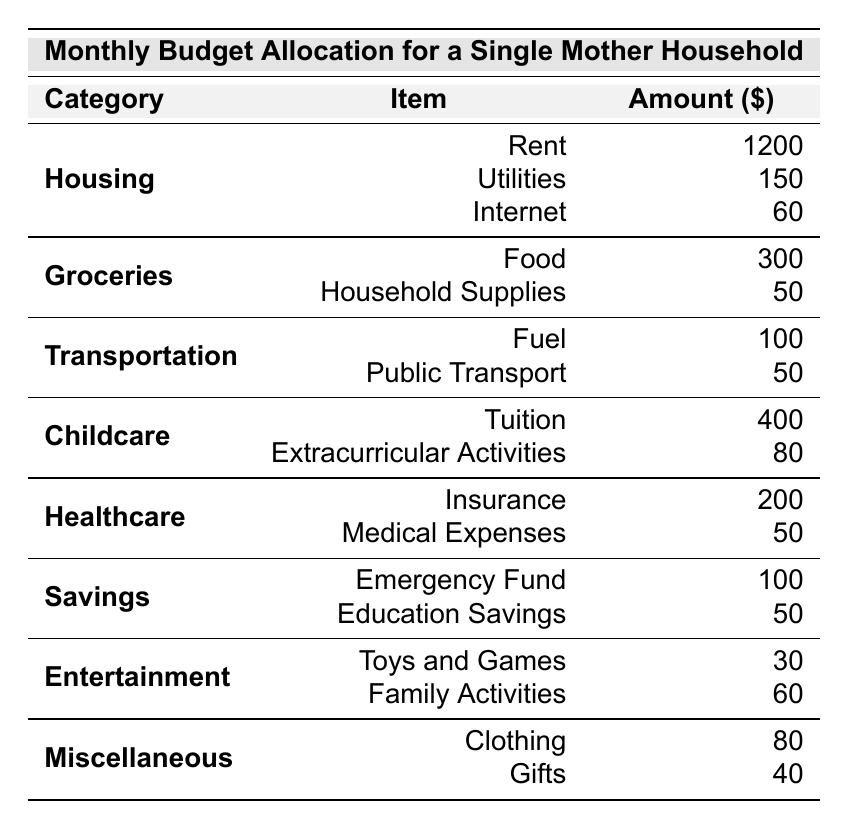What is the total amount allocated for Housing? To find the total, we add the allocations for Rent (1200), Utilities (150), and Internet (60). So, the total is 1200 + 150 + 60 = 1410.
Answer: 1410 How much more is spent on Groceries than on Transportation? The total for Groceries is 300 + 50 = 350, and the total for Transportation is 100 + 50 = 150. Subtract the Transportation total from the Groceries total: 350 - 150 = 200.
Answer: 200 What is the total budget for Childcare? The total for Childcare can be calculated by adding Tuition (400) and Extracurricular Activities (80), which gives us 400 + 80 = 480.
Answer: 480 Are the monthly expenses for Healthcare greater than those for Entertainment? The total for Healthcare is 200 + 50 = 250, whereas the total for Entertainment is 30 + 60 = 90. Since 250 is greater than 90, we confirm that it is true.
Answer: Yes What percentage of the total budget is allocated for Savings? First, calculate the total budget: 1200 + 150 + 60 + 300 + 50 + 100 + 50 + 400 + 80 + 200 + 50 + 100 + 50 + 30 + 60 + 80 + 40 =  2940. The total for Savings is 100 + 50 = 150. To find the percentage, we use the formula (150/2940) * 100 = approximately 5.1%.
Answer: 5.1% Which category has the highest individual expense? The highest individual expense is Rent under the Housing category, which is 1200.
Answer: Rent What is the cumulative amount spent on Miscellaneous items? To find the total for Miscellaneous, add Clothing (80) and Gifts (40): 80 + 40 = 120.
Answer: 120 If you want to reduce the budget for Entertainment by half, what will the new amount be? The original total for Entertainment is 30 + 60 = 90. Half of 90 is 45, which would be the new amount allocated if reduced by half.
Answer: 45 How much is spent on Healthcare compared to Childcare? The total for Healthcare is 200 + 50 = 250, and for Childcare, it is 400 + 80 = 480. Therefore, Childcare expenses are greater by 480 - 250 = 230.
Answer: 230 Which category accounts for the least amount of the budget, and what is that amount? The category with the least total is Entertainment (90: 30 for Toys and Games and 60 for Family Activities), which is less than any other category totals.
Answer: 90 